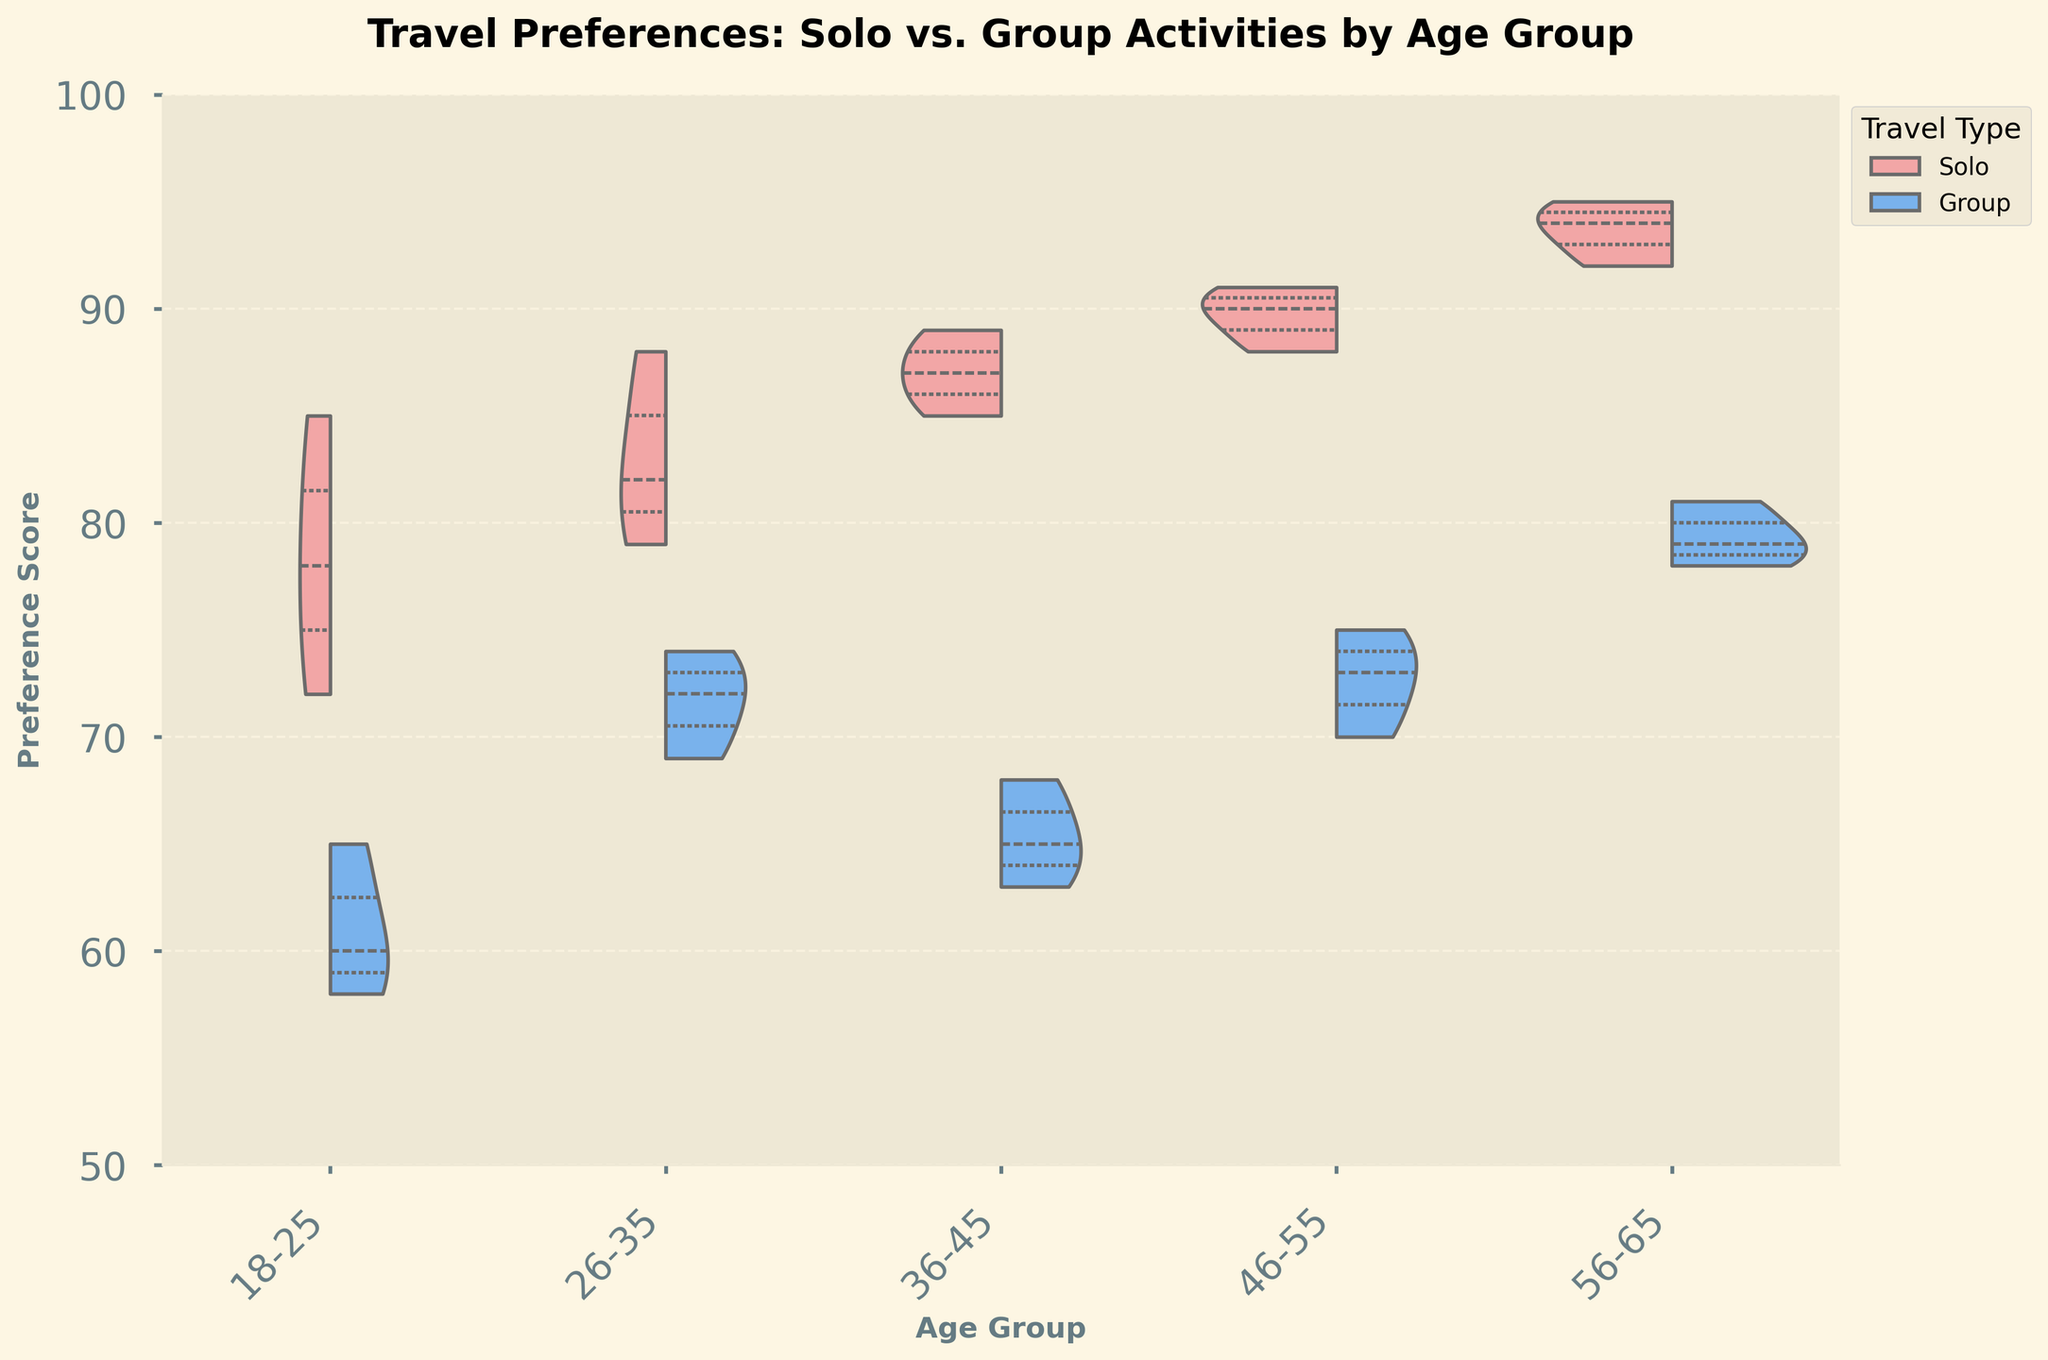what are the colors used for Solo and Group activities in the figure? Solo activities are represented by a pinkish-red color, and Group activities are represented by a blue color. The violin plots have these colors indicating the TravelType for better visualization.
Answer: Pinkish-red and blue What is the title of the figure? The title of the figure is given at the top and reads, "Travel Preferences: Solo vs. Group Activities by Age Group." This title provides context on what the chart is about.
Answer: Travel Preferences: Solo vs. Group Activities by Age Group Which age group shows the highest preference score for solo trips? By examining the plot, the age group 56-65 shows the highest preference scores for solo trips, with scores approaching 95 on the y-axis.
Answer: 56-65 What is the median preference score for group activities in the 36-45 age group? The median value in a violin plot is typically marked by a line inside the shape. For the 36-45 age group and Group activities, the median value falls close to 65 on the y-axis.
Answer: 65 In which age group is the difference in preference scores between solo and group activities the smallest? By comparing the ranges of preference scores in the violin plots for each age group, the smallest difference between solo and group activities appears in the 18-25 age group, where the scores for both travel types overlap significantly around the 60s and 70s.
Answer: 18-25 Which age group has the largest spread in preference scores for solo trips? The spread of the points can be seen by the width of the violin plot. The 56-65 age group has the widest plot for Solo trips, indicating a larger spread in preference scores.
Answer: 56-65 Are there any age groups where solo trips have a consistently higher preference score than group activities? For all age groups on the plot, solo trips generally show higher preference scores compared to group activities. This can be observed with the higher positioning and larger coverage of the solo trip plots in contrast to group activities within each age group.
Answer: Yes What is the range of preference scores for solo travel in the 26-35 age group? Observing the violin plot for the 26-35 age group, the range for solo travel is from around 79 to 88 on the y-axis.
Answer: 79-88 Which age group shows nearly equal preference scores for both solo and group activities? Based on the visualization, the 18-25 age group shows almost equal preference scores for solo and group activities, with both types showing scores in the 60s to low 80s range.
Answer: 18-25 Between the 26-35 and 46-55 age groups, which has higher overall preference scores for group activities? By comparing the median and range of the Group activity plots, it can be seen that the 46-55 age group has higher median scores and generally higher preference scores compared to the 26-35 age group.
Answer: 46-55 